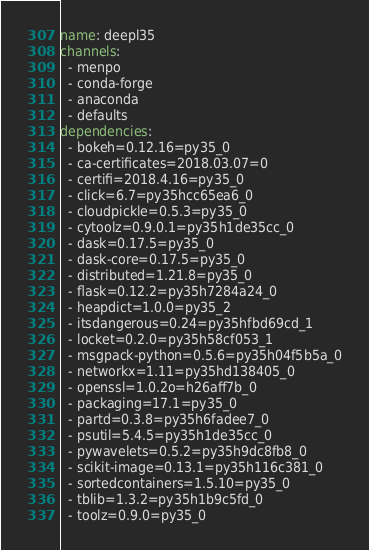<code> <loc_0><loc_0><loc_500><loc_500><_YAML_>name: deepl35
channels:
  - menpo
  - conda-forge
  - anaconda
  - defaults
dependencies:
  - bokeh=0.12.16=py35_0
  - ca-certificates=2018.03.07=0
  - certifi=2018.4.16=py35_0
  - click=6.7=py35hcc65ea6_0
  - cloudpickle=0.5.3=py35_0
  - cytoolz=0.9.0.1=py35h1de35cc_0
  - dask=0.17.5=py35_0
  - dask-core=0.17.5=py35_0
  - distributed=1.21.8=py35_0
  - flask=0.12.2=py35h7284a24_0
  - heapdict=1.0.0=py35_2
  - itsdangerous=0.24=py35hfbd69cd_1
  - locket=0.2.0=py35h58cf053_1
  - msgpack-python=0.5.6=py35h04f5b5a_0
  - networkx=1.11=py35hd138405_0
  - openssl=1.0.2o=h26aff7b_0
  - packaging=17.1=py35_0
  - partd=0.3.8=py35h6fadee7_0
  - psutil=5.4.5=py35h1de35cc_0
  - pywavelets=0.5.2=py35h9dc8fb8_0
  - scikit-image=0.13.1=py35h116c381_0
  - sortedcontainers=1.5.10=py35_0
  - tblib=1.3.2=py35h1b9c5fd_0
  - toolz=0.9.0=py35_0</code> 